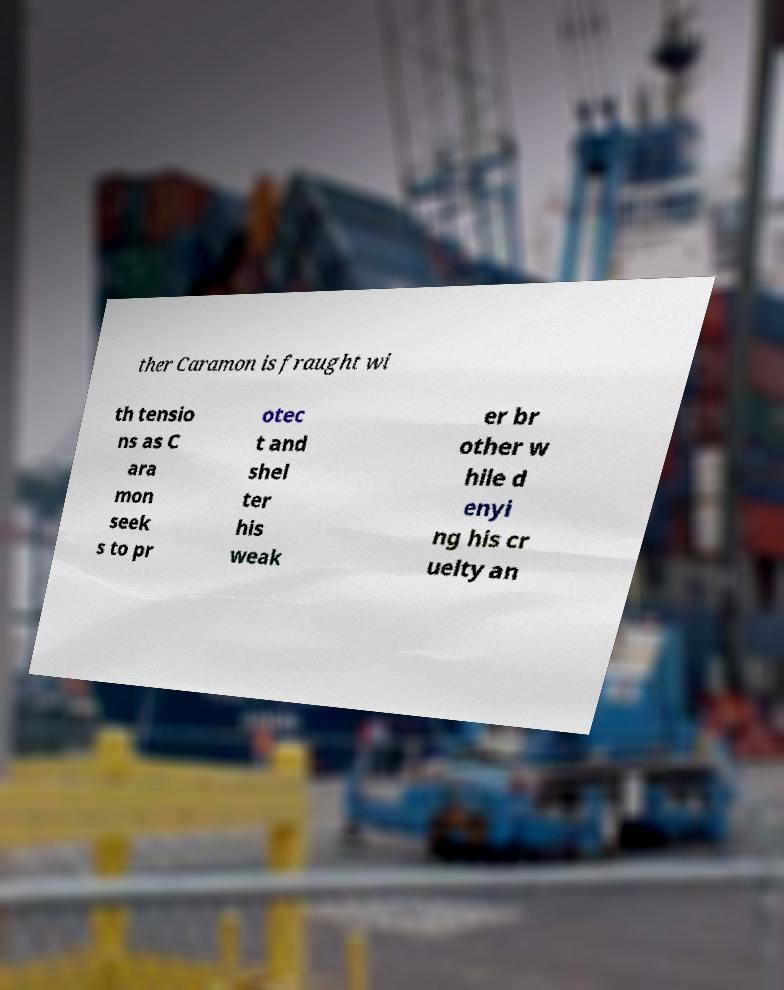Can you read and provide the text displayed in the image?This photo seems to have some interesting text. Can you extract and type it out for me? ther Caramon is fraught wi th tensio ns as C ara mon seek s to pr otec t and shel ter his weak er br other w hile d enyi ng his cr uelty an 